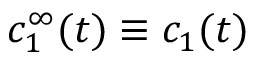Convert formula to latex. <formula><loc_0><loc_0><loc_500><loc_500>c _ { 1 } ^ { \infty } ( t ) \equiv c _ { 1 } ( t )</formula> 